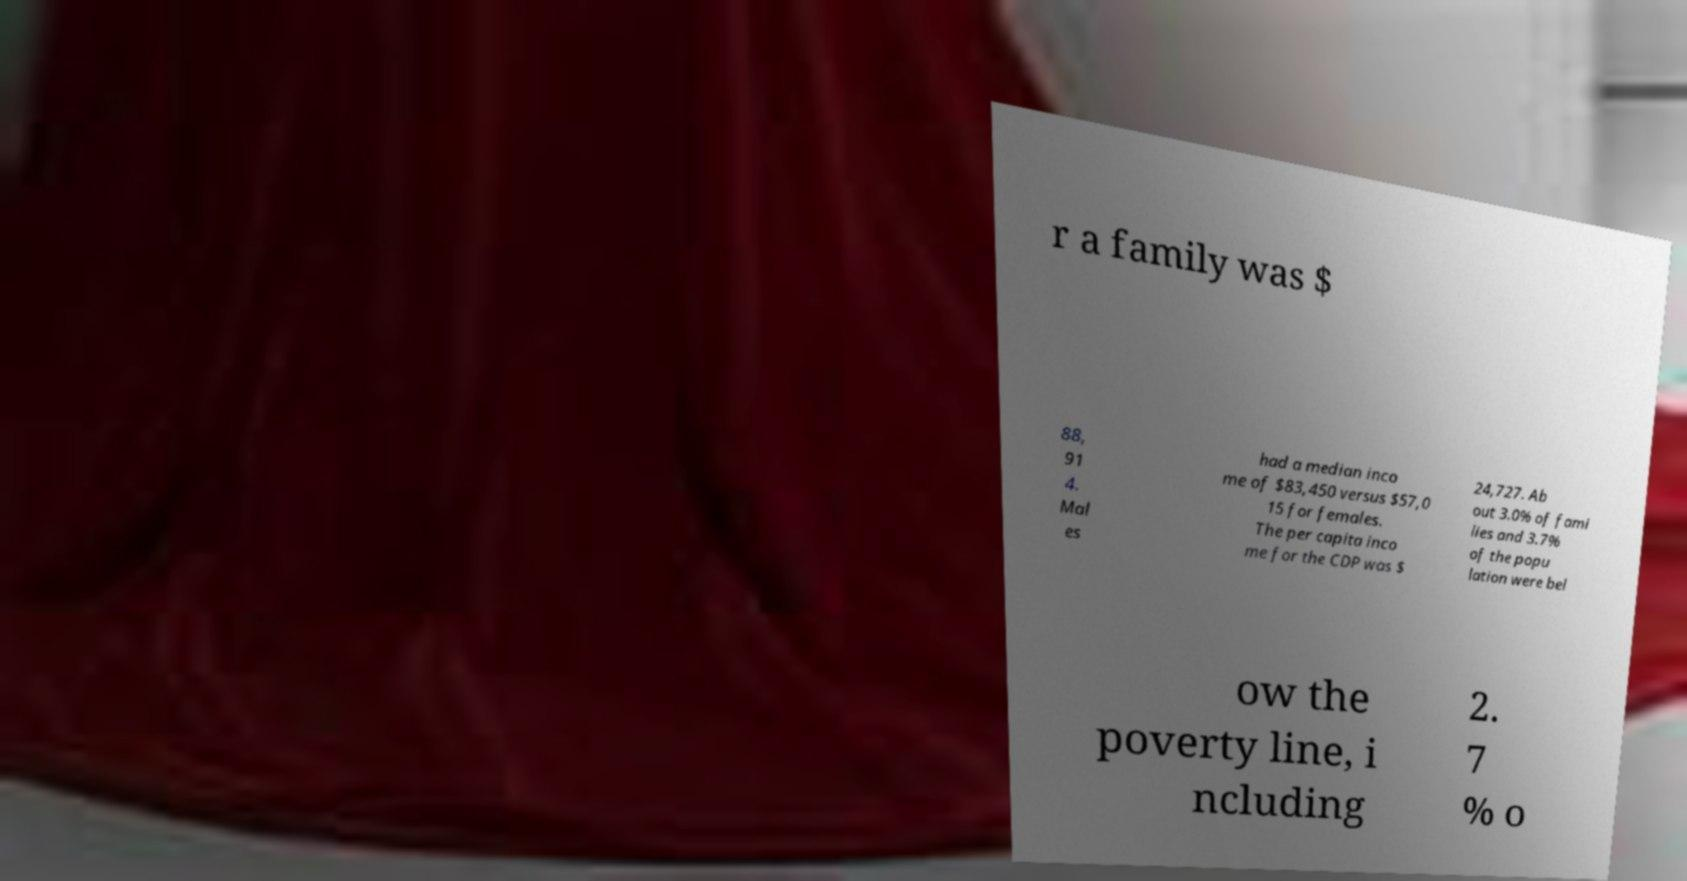Please identify and transcribe the text found in this image. r a family was $ 88, 91 4. Mal es had a median inco me of $83,450 versus $57,0 15 for females. The per capita inco me for the CDP was $ 24,727. Ab out 3.0% of fami lies and 3.7% of the popu lation were bel ow the poverty line, i ncluding 2. 7 % o 